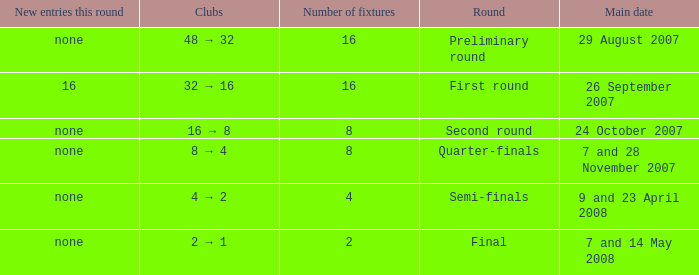What is the Round when the number of fixtures is more than 2, and the Main date of 7 and 28 november 2007? Quarter-finals. 